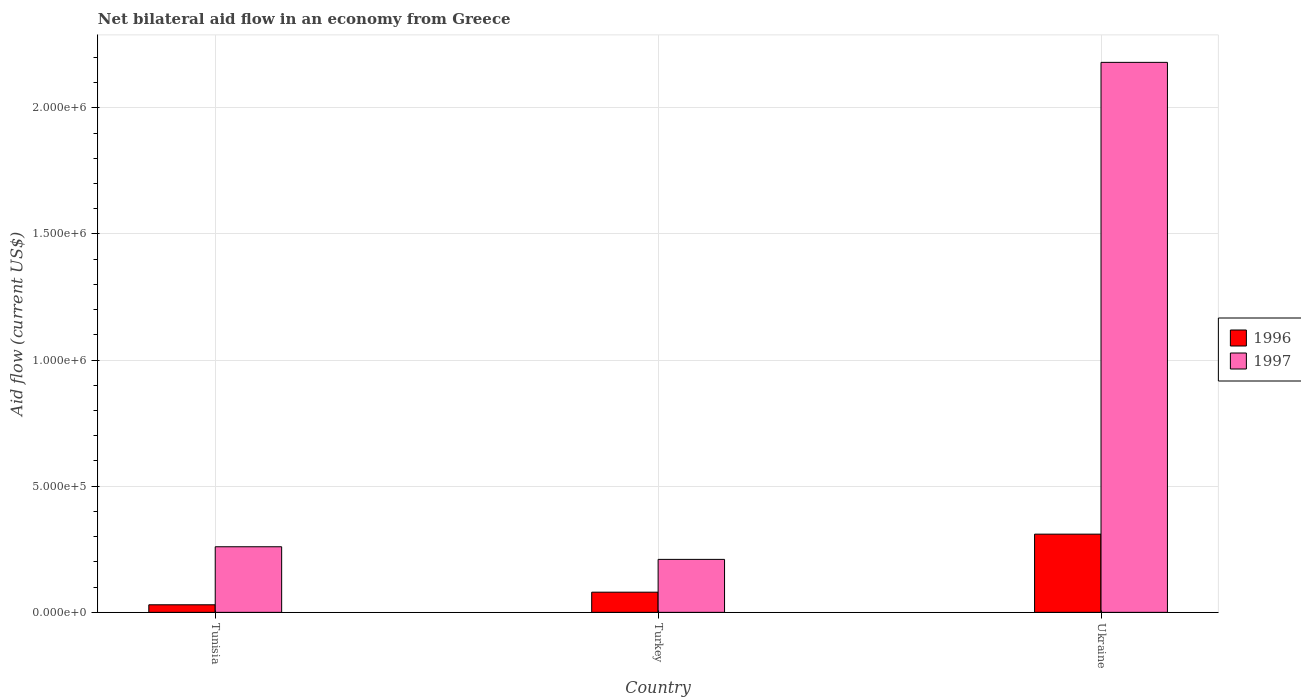How many different coloured bars are there?
Make the answer very short. 2. How many groups of bars are there?
Your answer should be very brief. 3. How many bars are there on the 1st tick from the left?
Ensure brevity in your answer.  2. What is the label of the 1st group of bars from the left?
Provide a short and direct response. Tunisia. In how many cases, is the number of bars for a given country not equal to the number of legend labels?
Ensure brevity in your answer.  0. Across all countries, what is the maximum net bilateral aid flow in 1997?
Offer a very short reply. 2.18e+06. In which country was the net bilateral aid flow in 1996 maximum?
Your response must be concise. Ukraine. In which country was the net bilateral aid flow in 1997 minimum?
Your answer should be compact. Turkey. What is the total net bilateral aid flow in 1997 in the graph?
Your response must be concise. 2.65e+06. What is the difference between the net bilateral aid flow in 1996 in Turkey and the net bilateral aid flow in 1997 in Tunisia?
Make the answer very short. -1.80e+05. What is the difference between the net bilateral aid flow of/in 1996 and net bilateral aid flow of/in 1997 in Ukraine?
Keep it short and to the point. -1.87e+06. In how many countries, is the net bilateral aid flow in 1997 greater than 2000000 US$?
Provide a succinct answer. 1. What is the ratio of the net bilateral aid flow in 1997 in Turkey to that in Ukraine?
Give a very brief answer. 0.1. Is the net bilateral aid flow in 1997 in Tunisia less than that in Ukraine?
Provide a short and direct response. Yes. Is the difference between the net bilateral aid flow in 1996 in Tunisia and Turkey greater than the difference between the net bilateral aid flow in 1997 in Tunisia and Turkey?
Offer a very short reply. No. What is the difference between the highest and the second highest net bilateral aid flow in 1997?
Provide a short and direct response. 1.97e+06. What is the difference between the highest and the lowest net bilateral aid flow in 1997?
Keep it short and to the point. 1.97e+06. In how many countries, is the net bilateral aid flow in 1997 greater than the average net bilateral aid flow in 1997 taken over all countries?
Provide a short and direct response. 1. Is the sum of the net bilateral aid flow in 1997 in Tunisia and Ukraine greater than the maximum net bilateral aid flow in 1996 across all countries?
Provide a succinct answer. Yes. What does the 1st bar from the left in Tunisia represents?
Offer a terse response. 1996. What does the 2nd bar from the right in Turkey represents?
Your response must be concise. 1996. Are all the bars in the graph horizontal?
Your answer should be compact. No. How many countries are there in the graph?
Your response must be concise. 3. What is the difference between two consecutive major ticks on the Y-axis?
Your answer should be very brief. 5.00e+05. Does the graph contain any zero values?
Keep it short and to the point. No. Does the graph contain grids?
Ensure brevity in your answer.  Yes. How are the legend labels stacked?
Offer a very short reply. Vertical. What is the title of the graph?
Make the answer very short. Net bilateral aid flow in an economy from Greece. What is the Aid flow (current US$) of 1996 in Tunisia?
Ensure brevity in your answer.  3.00e+04. What is the Aid flow (current US$) of 1997 in Tunisia?
Provide a succinct answer. 2.60e+05. What is the Aid flow (current US$) of 1996 in Ukraine?
Your answer should be very brief. 3.10e+05. What is the Aid flow (current US$) in 1997 in Ukraine?
Your response must be concise. 2.18e+06. Across all countries, what is the maximum Aid flow (current US$) of 1996?
Offer a very short reply. 3.10e+05. Across all countries, what is the maximum Aid flow (current US$) in 1997?
Provide a short and direct response. 2.18e+06. What is the total Aid flow (current US$) in 1996 in the graph?
Keep it short and to the point. 4.20e+05. What is the total Aid flow (current US$) in 1997 in the graph?
Make the answer very short. 2.65e+06. What is the difference between the Aid flow (current US$) of 1997 in Tunisia and that in Turkey?
Ensure brevity in your answer.  5.00e+04. What is the difference between the Aid flow (current US$) of 1996 in Tunisia and that in Ukraine?
Provide a succinct answer. -2.80e+05. What is the difference between the Aid flow (current US$) of 1997 in Tunisia and that in Ukraine?
Provide a short and direct response. -1.92e+06. What is the difference between the Aid flow (current US$) of 1997 in Turkey and that in Ukraine?
Give a very brief answer. -1.97e+06. What is the difference between the Aid flow (current US$) of 1996 in Tunisia and the Aid flow (current US$) of 1997 in Ukraine?
Provide a succinct answer. -2.15e+06. What is the difference between the Aid flow (current US$) of 1996 in Turkey and the Aid flow (current US$) of 1997 in Ukraine?
Your response must be concise. -2.10e+06. What is the average Aid flow (current US$) of 1996 per country?
Ensure brevity in your answer.  1.40e+05. What is the average Aid flow (current US$) in 1997 per country?
Offer a very short reply. 8.83e+05. What is the difference between the Aid flow (current US$) of 1996 and Aid flow (current US$) of 1997 in Turkey?
Provide a short and direct response. -1.30e+05. What is the difference between the Aid flow (current US$) of 1996 and Aid flow (current US$) of 1997 in Ukraine?
Provide a short and direct response. -1.87e+06. What is the ratio of the Aid flow (current US$) of 1996 in Tunisia to that in Turkey?
Provide a short and direct response. 0.38. What is the ratio of the Aid flow (current US$) of 1997 in Tunisia to that in Turkey?
Give a very brief answer. 1.24. What is the ratio of the Aid flow (current US$) of 1996 in Tunisia to that in Ukraine?
Offer a terse response. 0.1. What is the ratio of the Aid flow (current US$) in 1997 in Tunisia to that in Ukraine?
Your response must be concise. 0.12. What is the ratio of the Aid flow (current US$) in 1996 in Turkey to that in Ukraine?
Make the answer very short. 0.26. What is the ratio of the Aid flow (current US$) of 1997 in Turkey to that in Ukraine?
Make the answer very short. 0.1. What is the difference between the highest and the second highest Aid flow (current US$) in 1997?
Make the answer very short. 1.92e+06. What is the difference between the highest and the lowest Aid flow (current US$) of 1996?
Ensure brevity in your answer.  2.80e+05. What is the difference between the highest and the lowest Aid flow (current US$) of 1997?
Ensure brevity in your answer.  1.97e+06. 